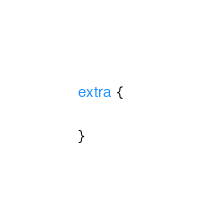Convert code to text. <code><loc_0><loc_0><loc_500><loc_500><_CSS_>extra {
	
}</code> 